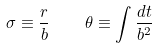<formula> <loc_0><loc_0><loc_500><loc_500>\sigma \equiv \frac { r } { b } \quad \theta \equiv \int \frac { d t } { b ^ { 2 } }</formula> 